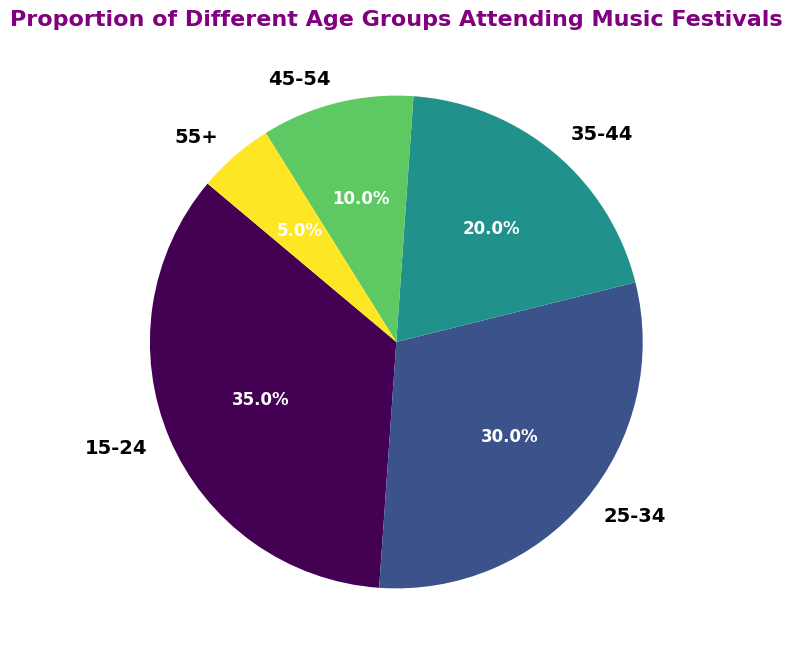Which age group has the highest proportion of attendees? By looking at the pie chart, the segment with the largest slice represents the age group with the highest proportion. Here, the 15-24 age group has the largest slice.
Answer: 15-24 Which age group accounts for the smallest proportion of attendees? By identifying the smallest slice of the chart, we see that the 55+ age group has the smallest proportion.
Answer: 55+ What is the combined percentage of attendees who are between the ages of 25 and 44? Adding the percentages of the 25-34 and 35-44 age groups: 30% + 20% = 50%
Answer: 50% Are there more attendees in the 35-44 age group or the 45-54 age group? By comparing the slices, the 35-44 age group (20%) has a larger proportion than the 45-54 age group (10%).
Answer: 35-44 How does the proportion of attendees aged 15-24 compare to those aged 55+? The 15-24 age group (35%) is significantly larger than the 55+ age group (5%).
Answer: 15-24 What is the average percentage of attendees for the three middle age groups (25-34, 35-44, 45-54)? Adding the percentages and dividing by 3: (30% + 20% + 10%) / 3 = 60% / 3 = 20%
Answer: 20% What percentage of attendees are aged 35 and older? Adding the percentages of the 35-44, 45-54, and 55+ age groups: 20% + 10% + 5% = 35%
Answer: 35% Which two age groups combined make up almost half of the attendees? Adding the percentages of different combinations, the 15-24 and 25-34 age groups: 35% + 30% = 65%, while the combined 25-34 and 35-44 ages groups: 30% + 20% = 50%, which is closest to half.
Answer: 25-34 and 35-44 Which age group has a percentage that is twice as large as the 45-54 age group? Comparing the percentages, the 35-44 age group (20%) is twice the percentage of the 45-54 age group (10%).
Answer: 35-44 